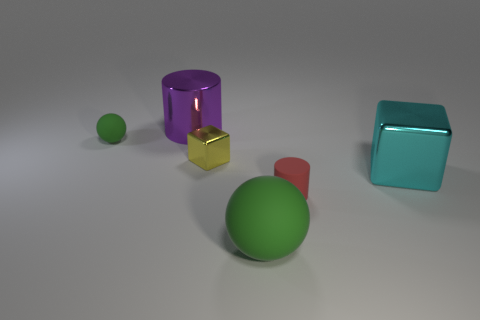Add 4 red things. How many objects exist? 10 Subtract all cubes. How many objects are left? 4 Add 4 small yellow things. How many small yellow things are left? 5 Add 4 small rubber cylinders. How many small rubber cylinders exist? 5 Subtract 0 red blocks. How many objects are left? 6 Subtract 1 cylinders. How many cylinders are left? 1 Subtract all yellow cylinders. Subtract all blue blocks. How many cylinders are left? 2 Subtract all blocks. Subtract all tiny matte balls. How many objects are left? 3 